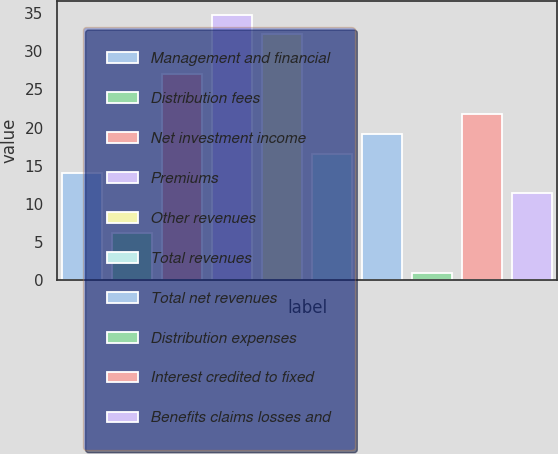<chart> <loc_0><loc_0><loc_500><loc_500><bar_chart><fcel>Management and financial<fcel>Distribution fees<fcel>Net investment income<fcel>Premiums<fcel>Other revenues<fcel>Total revenues<fcel>Total net revenues<fcel>Distribution expenses<fcel>Interest credited to fixed<fcel>Benefits claims losses and<nl><fcel>14<fcel>6.2<fcel>27<fcel>34.8<fcel>32.2<fcel>16.6<fcel>19.2<fcel>1<fcel>21.8<fcel>11.4<nl></chart> 